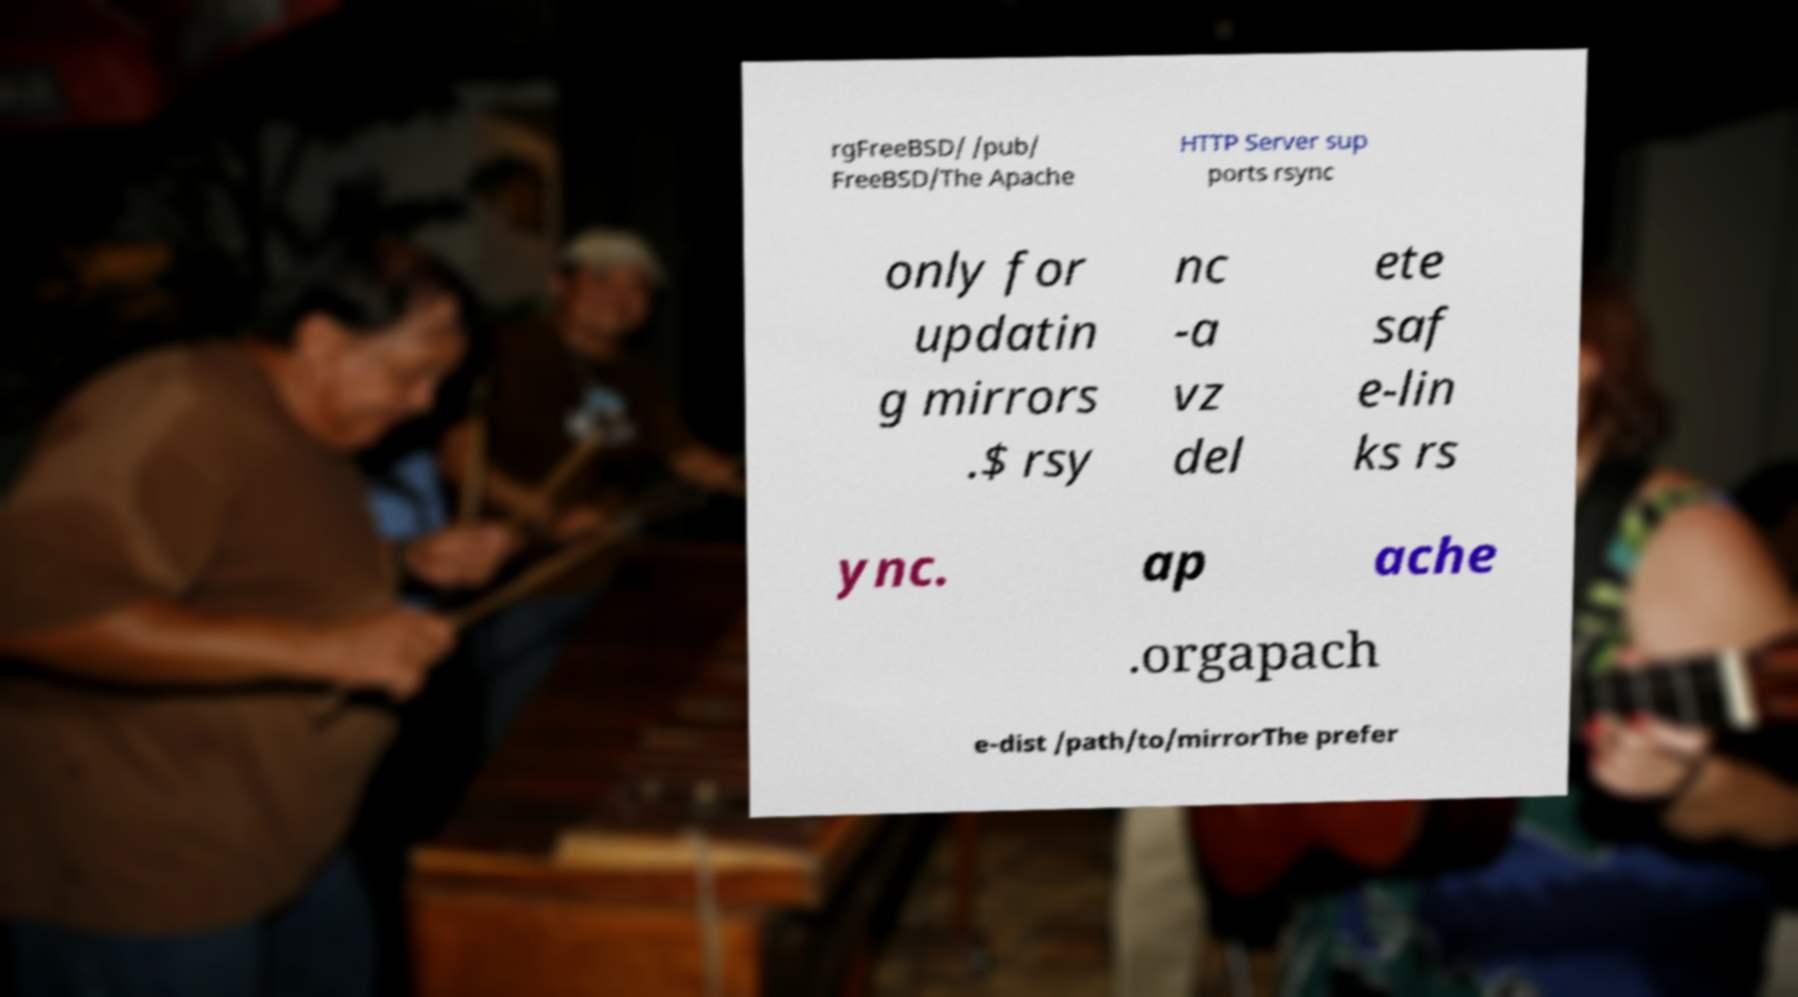Please read and relay the text visible in this image. What does it say? rgFreeBSD/ /pub/ FreeBSD/The Apache HTTP Server sup ports rsync only for updatin g mirrors .$ rsy nc -a vz del ete saf e-lin ks rs ync. ap ache .orgapach e-dist /path/to/mirrorThe prefer 